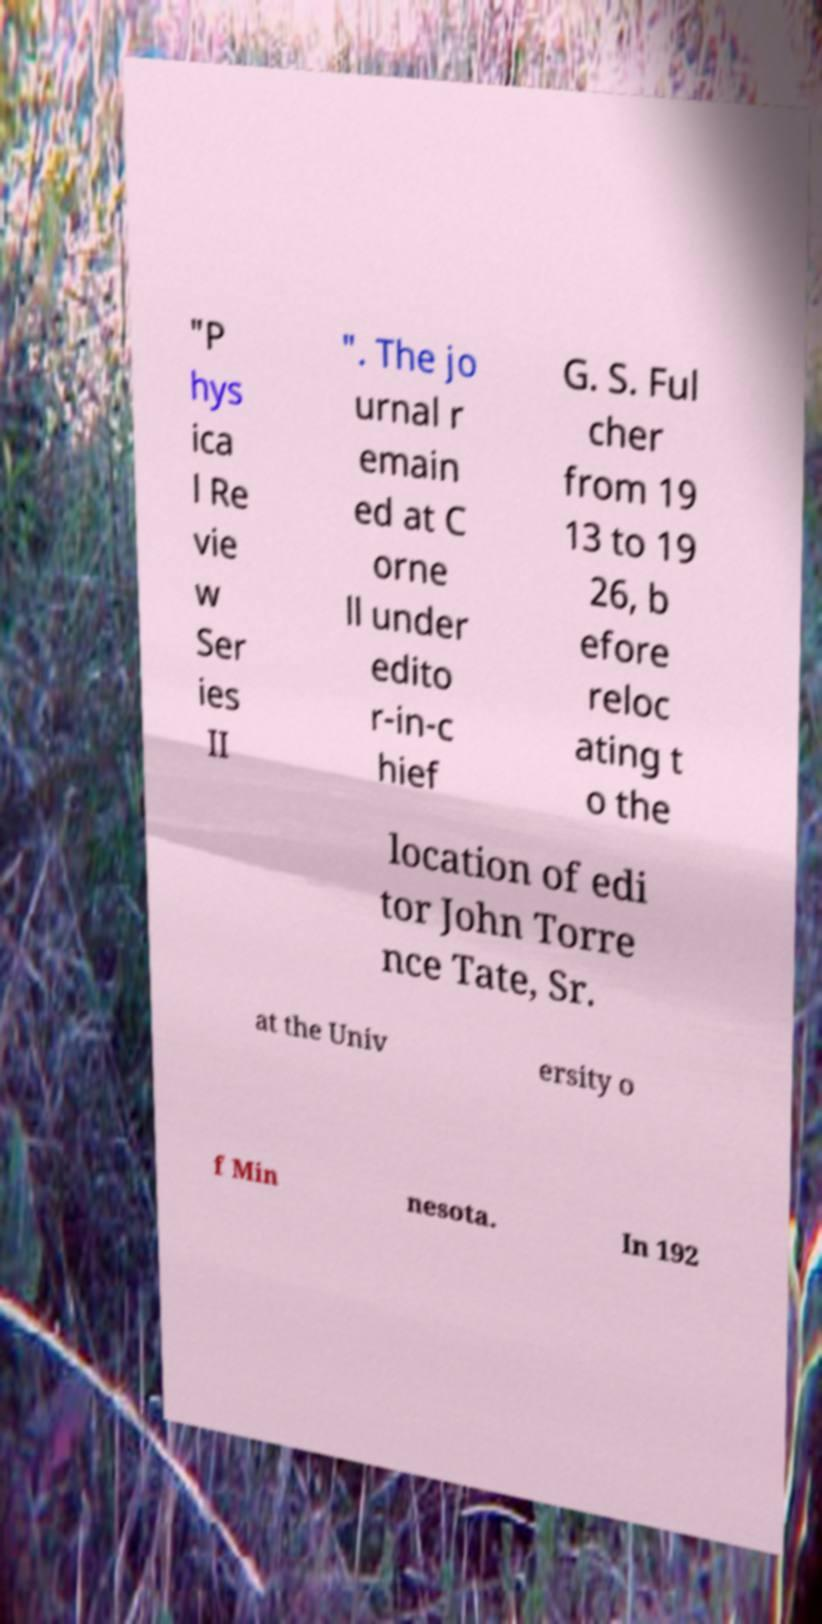Please identify and transcribe the text found in this image. "P hys ica l Re vie w Ser ies II ". The jo urnal r emain ed at C orne ll under edito r-in-c hief G. S. Ful cher from 19 13 to 19 26, b efore reloc ating t o the location of edi tor John Torre nce Tate, Sr. at the Univ ersity o f Min nesota. In 192 